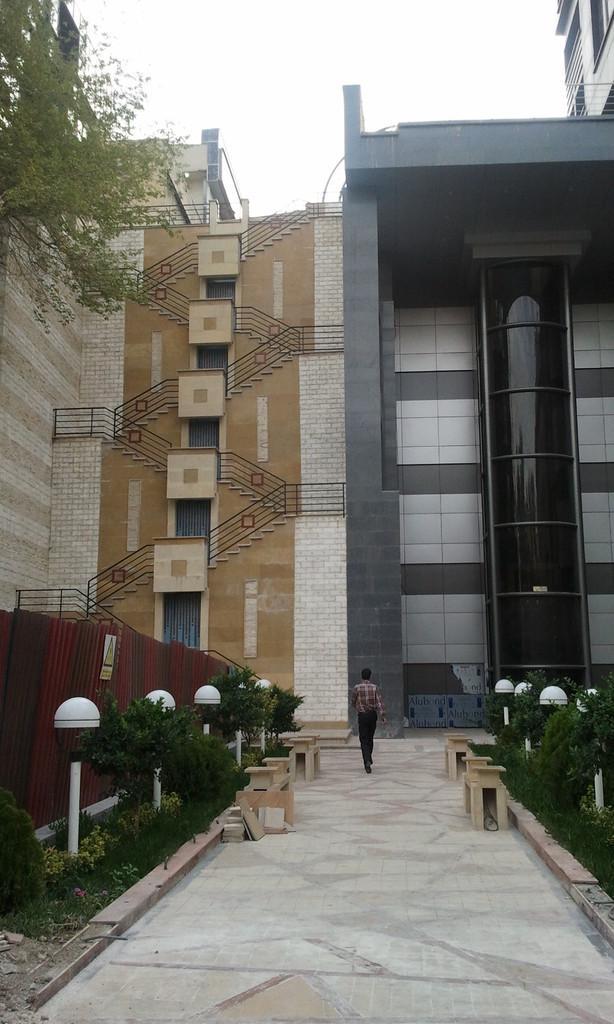How would you summarize this image in a sentence or two? At the bottom there is a man walking towards the back side. On the right and left side of the image there are few tables, plants and light poles. On the left side there is a fencing. In the middle of the image there are buildings. At the top of the image I can see the sky. In the top left-hand corner few leaves are visible. 